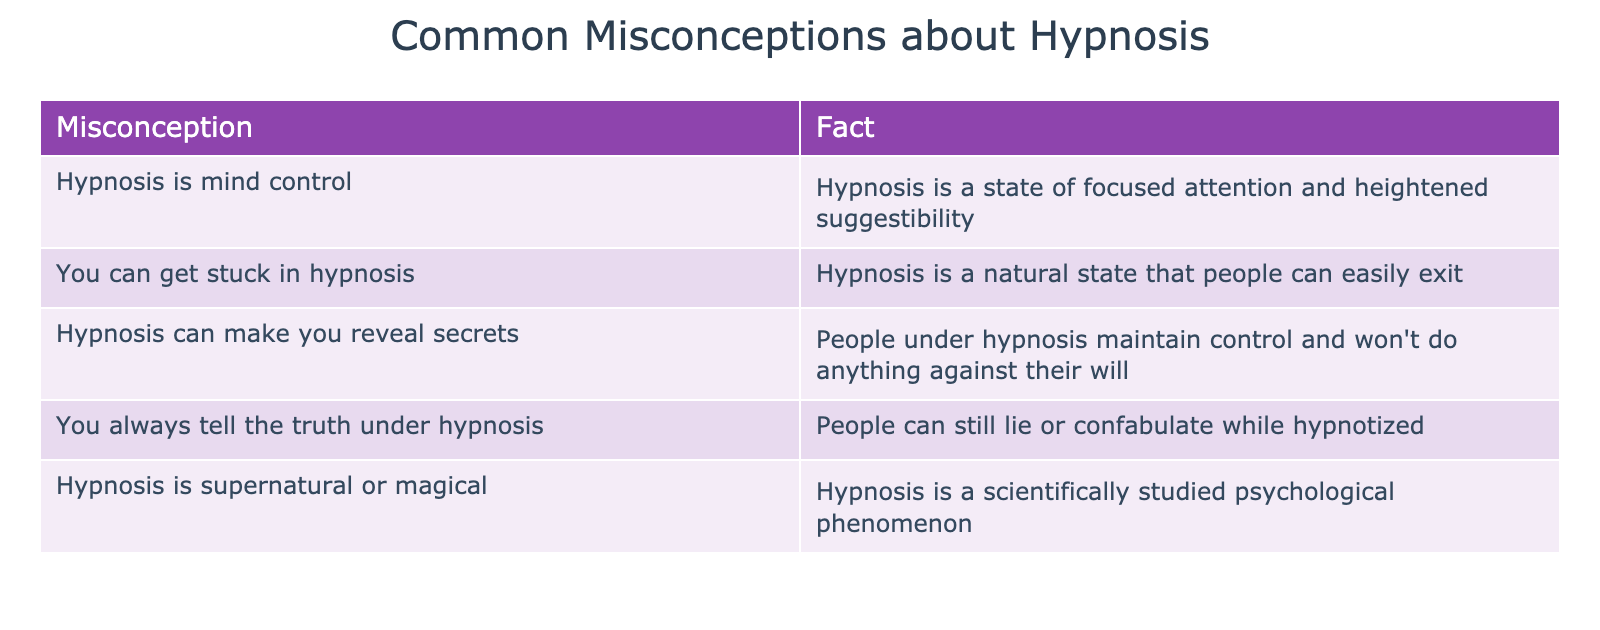What is the misconception associated with hypnosis being mind control? The table explicitly states that the misconception is “Hypnosis is mind control.” Therefore, we can directly retrieve this information from the table.
Answer: Hypnosis is mind control What fact counters the notion that you can get stuck in hypnosis? According to the table, the fact that counters this misconception is “Hypnosis is a natural state that people can easily exit.” This can be found directly in the corresponding row of the table.
Answer: Hypnosis is a natural state that people can easily exit Is it true that people under hypnosis reveal secrets? The table states in the respective row that “People under hypnosis maintain control and won't do anything against their will.” This means the fact contradicts the idea that secrets can be revealed.
Answer: No What are the two misconceptions related to truthfulness and lying under hypnosis? From the table, we see that one misconception is “You always tell the truth under hypnosis,” and another is “Hypnosis can make you reveal secrets.” These two misconceptions pertain to the truthfulness of individuals under hypnosis.
Answer: You always tell the truth under hypnosis; Hypnosis can make you reveal secrets Which misconception has a corresponding fact that is scientifically backed? The misconception “Hypnosis is supernatural or magical” has the corresponding fact “Hypnosis is a scientifically studied psychological phenomenon.” This can be found in the last row of the table, indicating a factual basis for the understanding of hypnosis.
Answer: Hypnosis is supernatural or magical How many misconceptions presented in the table are related to control over the individual? There are three instances related to control: “Hypnosis is mind control,” “You can get stuck in hypnosis,” and “Hypnosis can make you reveal secrets.” Thus, when counting these items, we find that there are three misconceptions regarding control.
Answer: Three What is the average length of misconceptions listed in the table? The misconceptions listed are: 23 characters for “Hypnosis is mind control,” 24 for “You can get stuck in hypnosis,” 31 for “Hypnosis can make you reveal secrets,” 31 for “You always tell the truth under hypnosis,” and 40 for “Hypnosis is supernatural or magical.” Calculating, the sum of characters is 179, and since there are 5 misconceptions, the average length is 179/5 = 35.8.
Answer: 35.8 List all misconceptions that imply control over someone during hypnosis. The misconceptions that imply control are “Hypnosis is mind control,” “You can get stuck in hypnosis,” and “Hypnosis can make you reveal secrets.” These three can be identified directly from the table.
Answer: Hypnosis is mind control; You can get stuck in hypnosis; Hypnosis can make you reveal secrets 